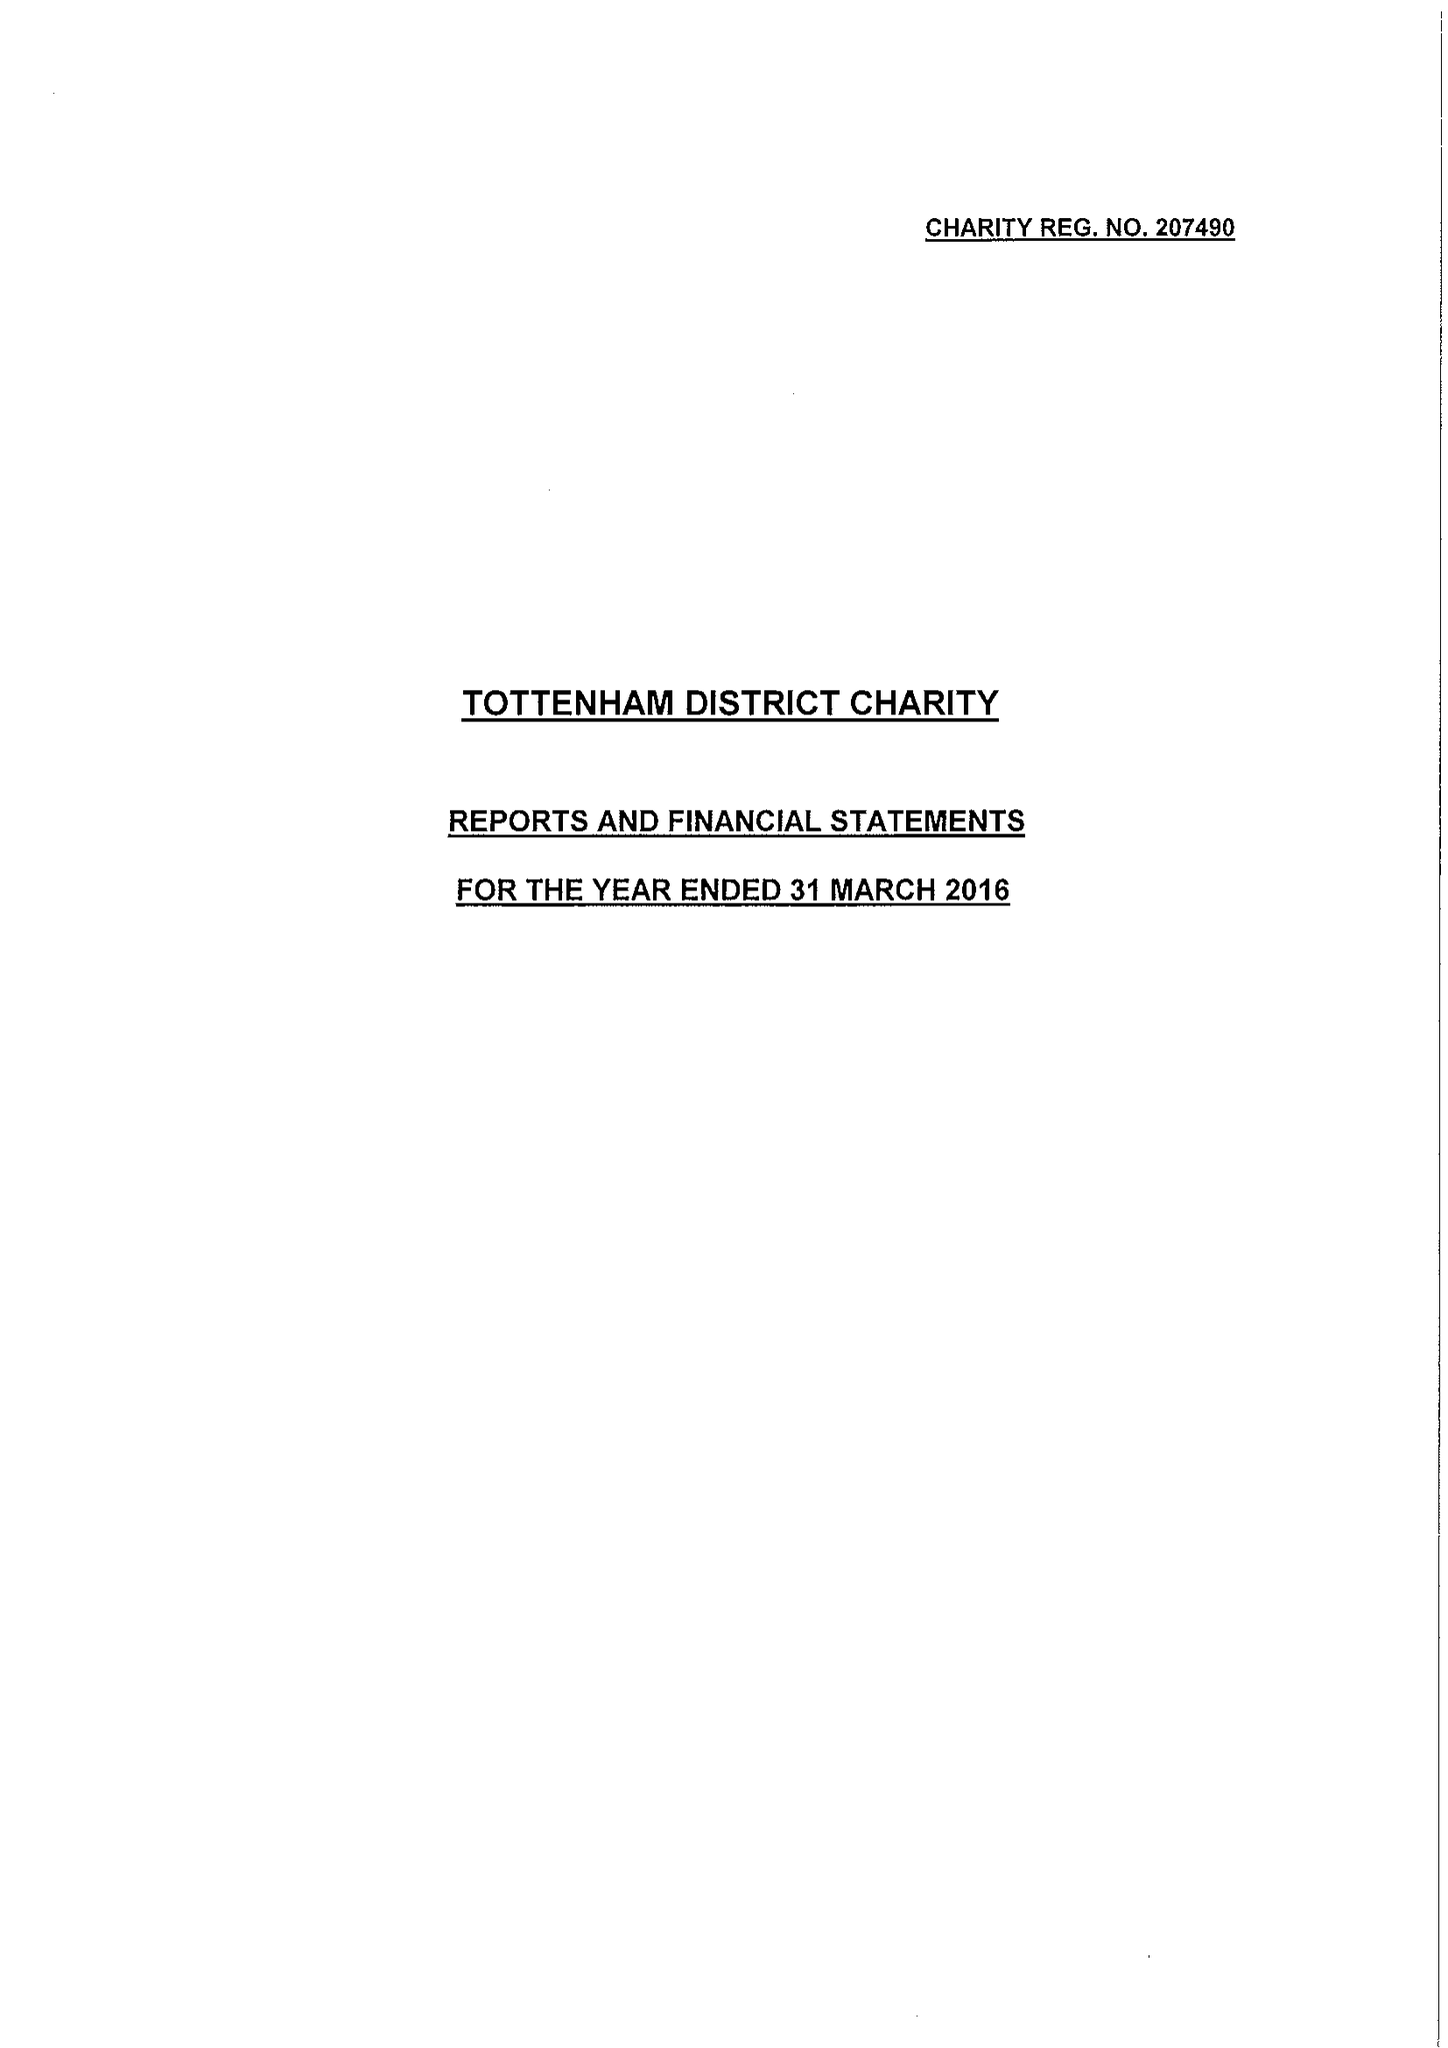What is the value for the address__post_town?
Answer the question using a single word or phrase. LONDON 